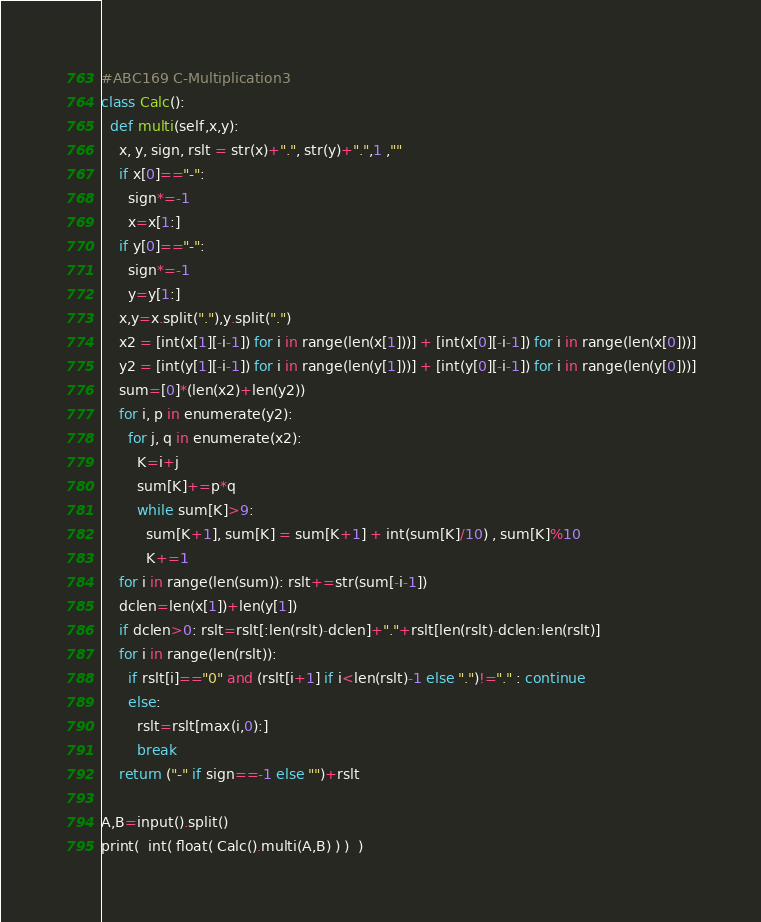Convert code to text. <code><loc_0><loc_0><loc_500><loc_500><_Python_>#ABC169 C-Multiplication3
class Calc():
  def multi(self,x,y):
    x, y, sign, rslt = str(x)+".", str(y)+".",1 ,""
    if x[0]=="-":
      sign*=-1
      x=x[1:]
    if y[0]=="-":
      sign*=-1
      y=y[1:]
    x,y=x.split("."),y.split(".")
    x2 = [int(x[1][-i-1]) for i in range(len(x[1]))] + [int(x[0][-i-1]) for i in range(len(x[0]))]
    y2 = [int(y[1][-i-1]) for i in range(len(y[1]))] + [int(y[0][-i-1]) for i in range(len(y[0]))]
    sum=[0]*(len(x2)+len(y2))
    for i, p in enumerate(y2):
      for j, q in enumerate(x2):
        K=i+j
        sum[K]+=p*q
        while sum[K]>9:
          sum[K+1], sum[K] = sum[K+1] + int(sum[K]/10) , sum[K]%10
          K+=1
    for i in range(len(sum)): rslt+=str(sum[-i-1])
    dclen=len(x[1])+len(y[1])
    if dclen>0: rslt=rslt[:len(rslt)-dclen]+"."+rslt[len(rslt)-dclen:len(rslt)]
    for i in range(len(rslt)):
      if rslt[i]=="0" and (rslt[i+1] if i<len(rslt)-1 else ".")!="." : continue
      else:
        rslt=rslt[max(i,0):]
        break
    return ("-" if sign==-1 else "")+rslt

A,B=input().split()
print(  int( float( Calc().multi(A,B) ) )  )</code> 